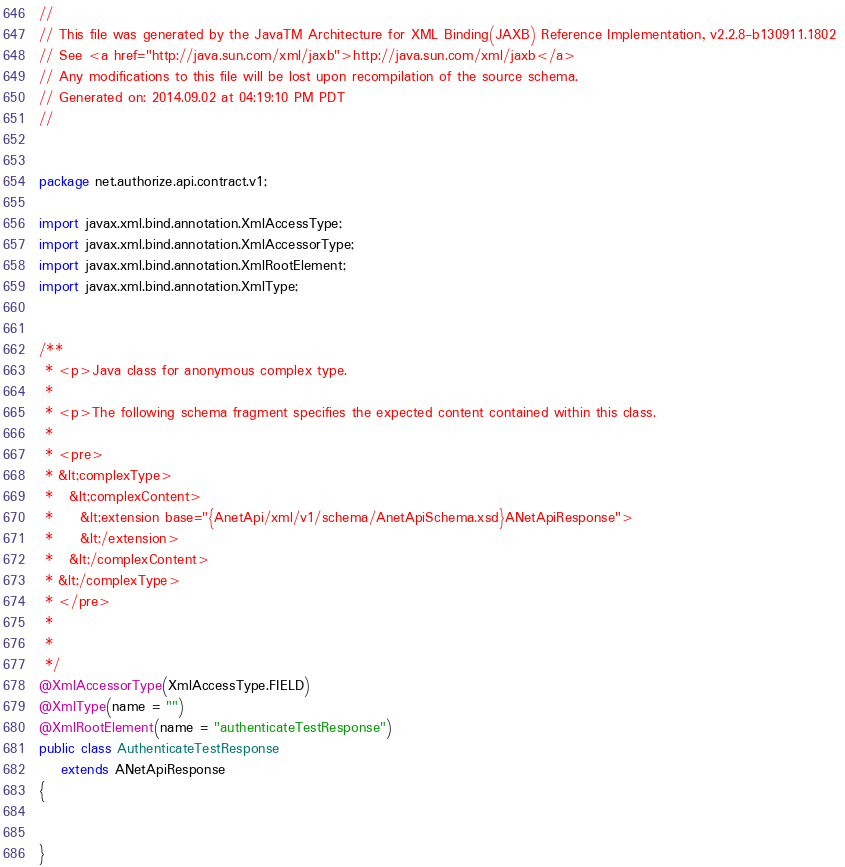<code> <loc_0><loc_0><loc_500><loc_500><_Java_>//
// This file was generated by the JavaTM Architecture for XML Binding(JAXB) Reference Implementation, v2.2.8-b130911.1802 
// See <a href="http://java.sun.com/xml/jaxb">http://java.sun.com/xml/jaxb</a> 
// Any modifications to this file will be lost upon recompilation of the source schema. 
// Generated on: 2014.09.02 at 04:19:10 PM PDT 
//


package net.authorize.api.contract.v1;

import javax.xml.bind.annotation.XmlAccessType;
import javax.xml.bind.annotation.XmlAccessorType;
import javax.xml.bind.annotation.XmlRootElement;
import javax.xml.bind.annotation.XmlType;


/**
 * <p>Java class for anonymous complex type.
 * 
 * <p>The following schema fragment specifies the expected content contained within this class.
 * 
 * <pre>
 * &lt;complexType>
 *   &lt;complexContent>
 *     &lt;extension base="{AnetApi/xml/v1/schema/AnetApiSchema.xsd}ANetApiResponse">
 *     &lt;/extension>
 *   &lt;/complexContent>
 * &lt;/complexType>
 * </pre>
 * 
 * 
 */
@XmlAccessorType(XmlAccessType.FIELD)
@XmlType(name = "")
@XmlRootElement(name = "authenticateTestResponse")
public class AuthenticateTestResponse
    extends ANetApiResponse
{


}
</code> 